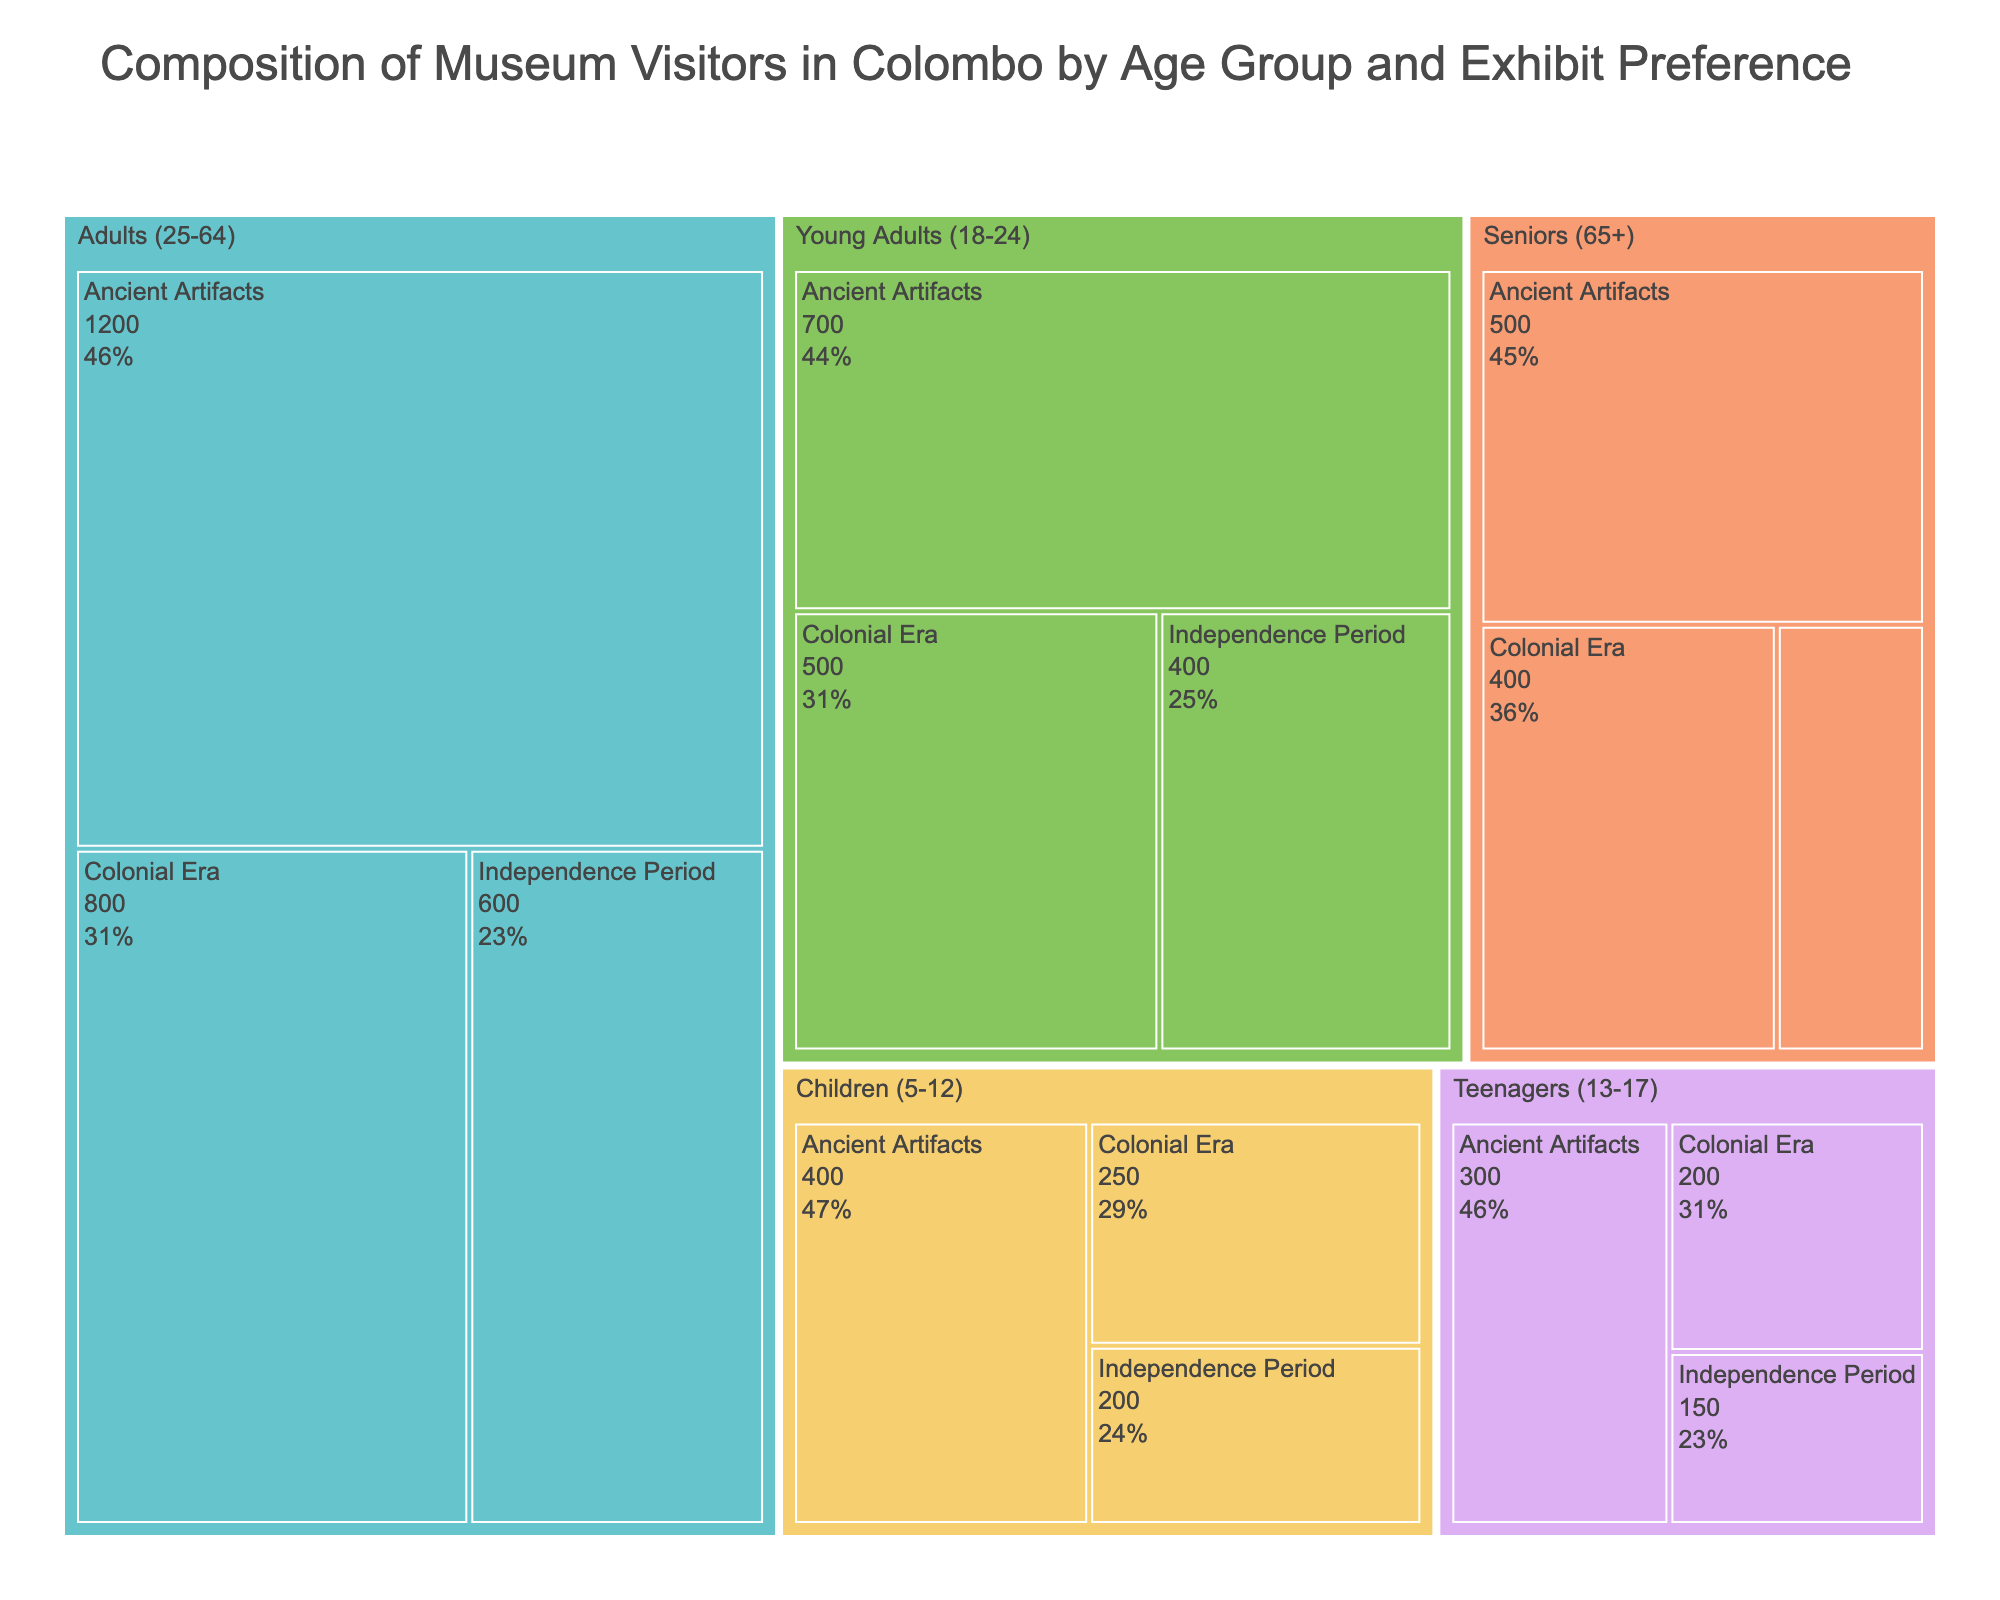How many visitors in total are from the Adults (25-64) age group? Add the number of visitors for each exhibit preference in the Adults (25-64) age group: 1200 (Ancient Artifacts) + 800 (Colonial Era) + 600 (Independence Period). The total is 2600.
Answer: 2600 Which exhibit type has the most visitors across all age groups? Sum the number of visitors for each exhibit type across all age groups: Ancient Artifacts (1200 + 500 + 700 + 300 + 400 = 3100), Colonial Era (800 + 400 + 500 + 200 + 250 = 2150), Independence Period (600 + 200 + 400 + 150 + 200 = 1550). Ancient Artifacts has the most visitors.
Answer: Ancient Artifacts What percentage of the total visitors are Senior (65+) visitors interested in Colonial Era exhibits? First, determine the total number of visitors: 3100 (Ancient Artifacts) + 2150 (Colonial Era) + 1550 (Independence Period) = 6800 visitors. Then, calculate the percentage: (400 / 6800) * 100 ≈ 5.88%.
Answer: ~5.88% Among the Young Adults (18-24), which exhibit has the least number of visitors? Compare the number of visitors for each exhibit type in the Young Adults (18-24) age group: Ancient Artifacts (700), Colonial Era (500), Independence Period (400). Independence Period has the least visitors.
Answer: Independence Period How many more visitors are interested in Ancient Artifacts compared to Independence Period across all age groups? Calculate the difference between the number of visitors for Ancient Artifacts and Independence Period: 3100 (Ancient Artifacts) - 1550 (Independence Period) = 1550.
Answer: 1550 What is the total number of visitors in the Teenagers (13-17) age group? Sum the number of visitors for each exhibit preference in the Teenagers (13-17) age group: 300 (Ancient Artifacts) + 200 (Colonial Era) + 150 (Independence Period). The total is 650.
Answer: 650 Which age group has the highest interest in Independence Period exhibits? Compare the number of visitors for Independence Period in each age group: Adults (25-64) (600), Seniors (65+) (200), Young Adults (18-24) (400), Teenagers (13-17) (150), Children (5-12) (200). Adults (25-64) have the highest interest.
Answer: Adults (25-64) If we combine the numbers of visitors for the Children (5-12) and Teenagers (13-17) age groups, which exhibit type attracts the most visitors? Sum the visitors for Children and Teenagers for each exhibit type: 
Ancient Artifacts: 400 (Children) + 300 (Teenagers) = 700
Colonial Era: 250 (Children) + 200 (Teenagers) = 450
Independence Period: 200 (Children) + 150 (Teenagers) = 350
Ancient Artifacts attracts the most visitors.
Answer: Ancient Artifacts What is the average number of visitors per exhibit for the Seniors (65+) age group? Sum the number of visitors for all exhibit types in the Seniors (65+) age group: 500 (Ancient Artifacts) + 400 (Colonial Era) + 200 (Independence Period) = 1100. Then, divide by the number of exhibit types (3): 1100 / 3 ≈ 366.67.
Answer: ≈ 366.67 